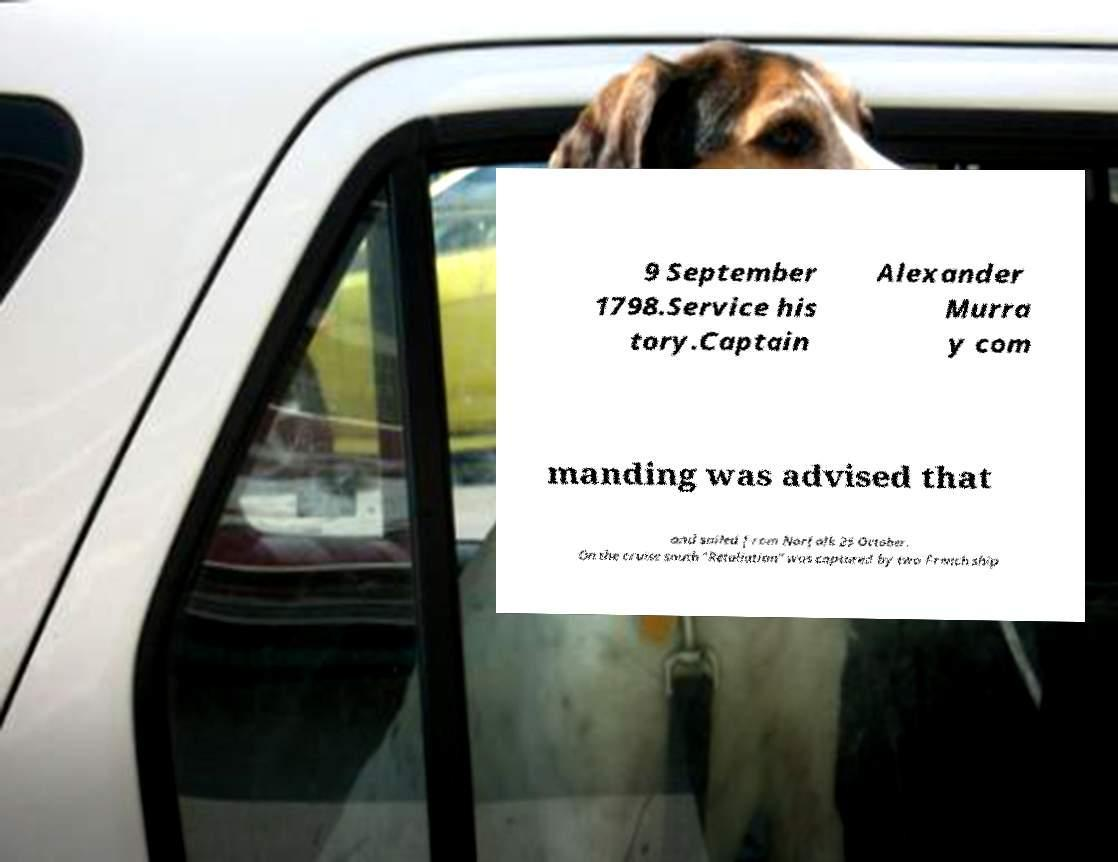Can you read and provide the text displayed in the image?This photo seems to have some interesting text. Can you extract and type it out for me? 9 September 1798.Service his tory.Captain Alexander Murra y com manding was advised that and sailed from Norfolk 25 October. On the cruise south "Retaliation" was captured by two French ship 